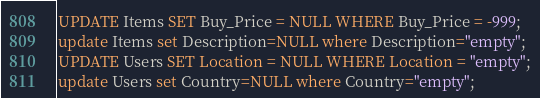Convert code to text. <code><loc_0><loc_0><loc_500><loc_500><_SQL_>UPDATE Items SET Buy_Price = NULL WHERE Buy_Price = -999;
update Items set Description=NULL where Description="empty";
UPDATE Users SET Location = NULL WHERE Location = "empty";
update Users set Country=NULL where Country="empty";</code> 